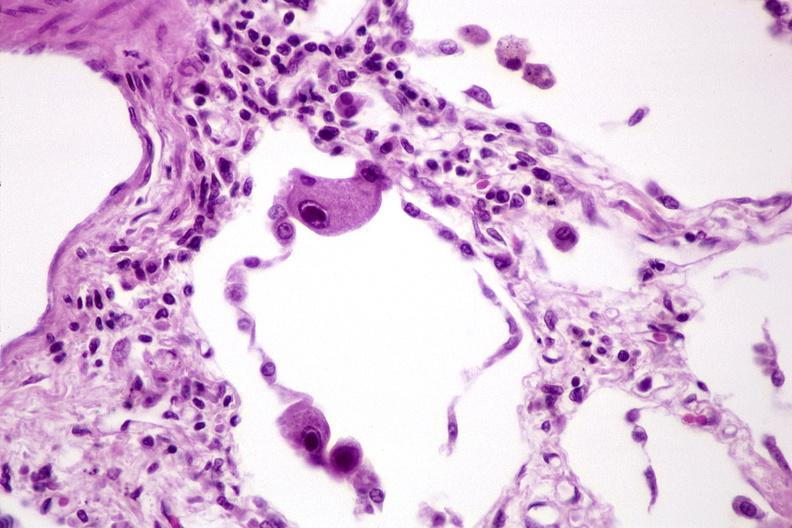where is this?
Answer the question using a single word or phrase. Lung 